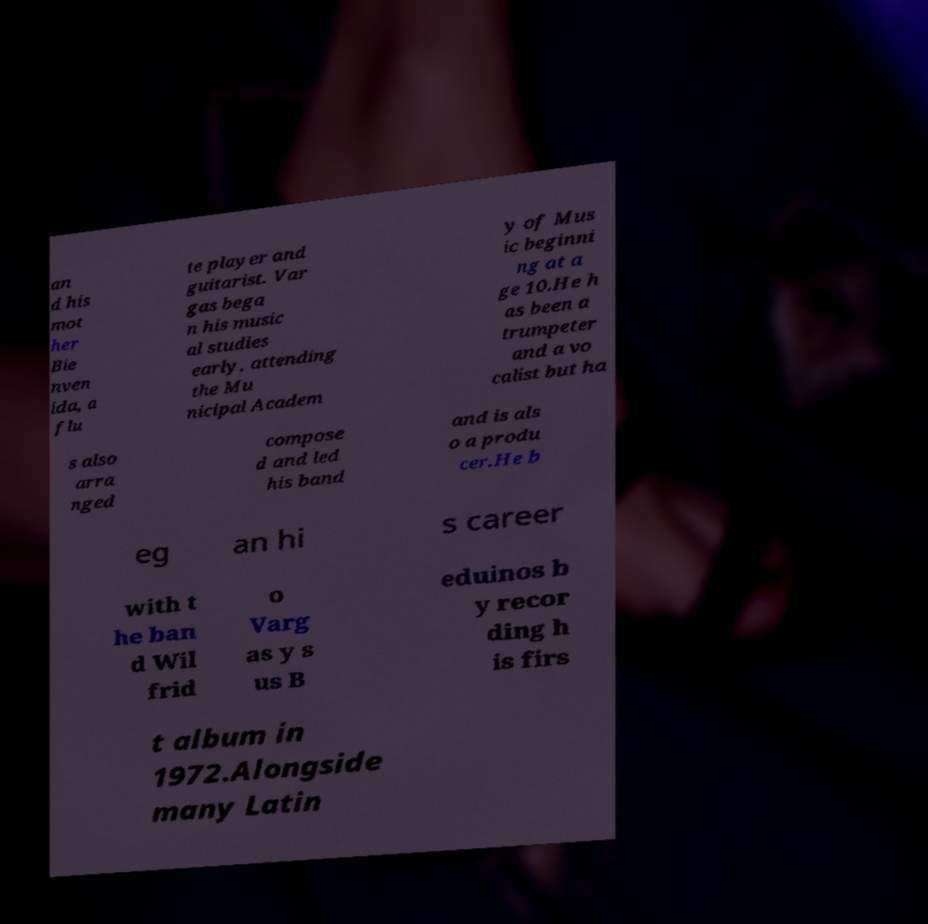There's text embedded in this image that I need extracted. Can you transcribe it verbatim? an d his mot her Bie nven ida, a flu te player and guitarist. Var gas bega n his music al studies early, attending the Mu nicipal Academ y of Mus ic beginni ng at a ge 10.He h as been a trumpeter and a vo calist but ha s also arra nged compose d and led his band and is als o a produ cer.He b eg an hi s career with t he ban d Wil frid o Varg as y s us B eduinos b y recor ding h is firs t album in 1972.Alongside many Latin 